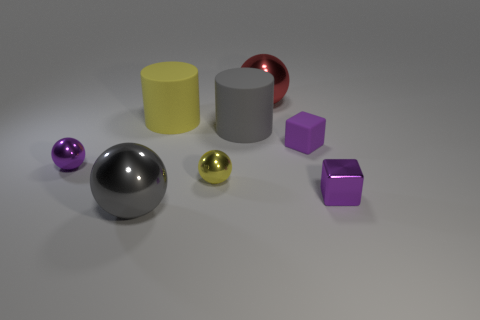Are there any matte objects that have the same color as the tiny shiny block?
Offer a very short reply. Yes. There is a block that is the same color as the small rubber object; what material is it?
Offer a terse response. Metal. There is a rubber thing that is the same size as the yellow rubber cylinder; what shape is it?
Provide a succinct answer. Cylinder. Is there a small purple thing that has the same shape as the yellow shiny thing?
Offer a terse response. Yes. Is the number of gray rubber cylinders less than the number of small green spheres?
Keep it short and to the point. No. Do the object that is to the left of the big gray metal sphere and the purple cube in front of the yellow sphere have the same size?
Offer a terse response. Yes. What number of things are either large yellow rubber cylinders or big gray shiny spheres?
Your answer should be compact. 2. How big is the metal block in front of the large gray rubber cylinder?
Offer a terse response. Small. How many red balls are behind the tiny purple cube that is behind the tiny metal thing that is on the right side of the red shiny thing?
Give a very brief answer. 1. Does the matte cube have the same color as the small metallic cube?
Offer a very short reply. Yes. 